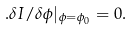Convert formula to latex. <formula><loc_0><loc_0><loc_500><loc_500>. \delta I / \delta \phi | _ { \phi = \phi _ { 0 } } = 0 .</formula> 